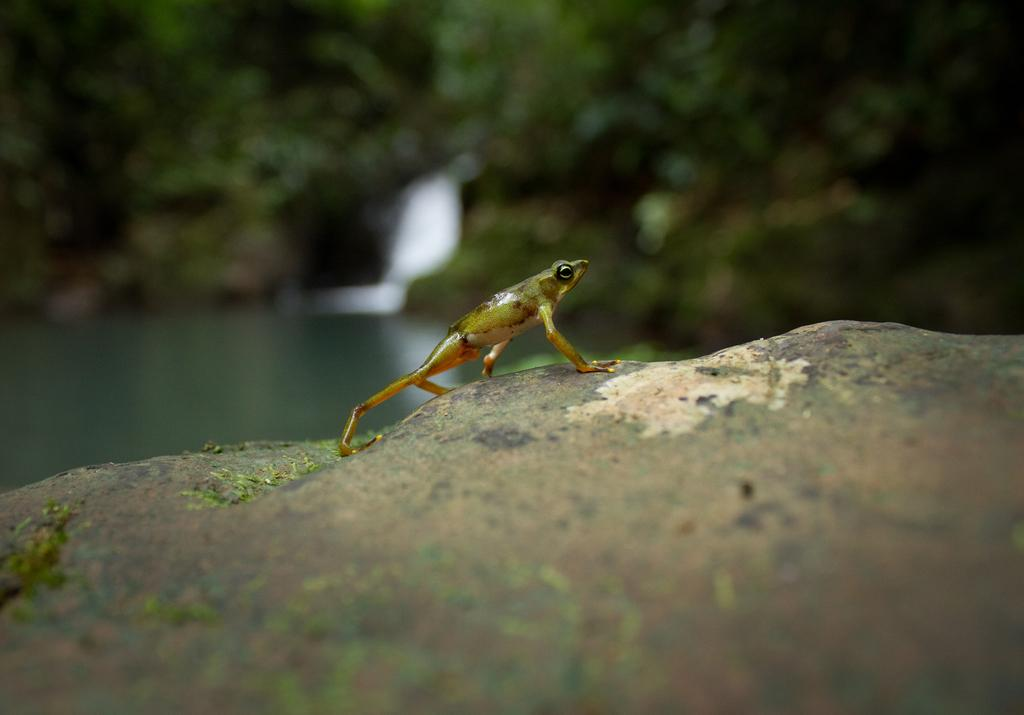What type of animal is in the image? There is an amphibian in the image. What color is the amphibian? The amphibian is green in color. Where is the amphibian located in the image? The amphibian is on a stone. What can be seen in the background of the image? There are trees and water visible in the background of the image. How many pizzas are being served by the giraffe on the ship in the image? There is no giraffe, ship, or pizzas present in the image. The image features an amphibian on a stone with trees and water in the background. 